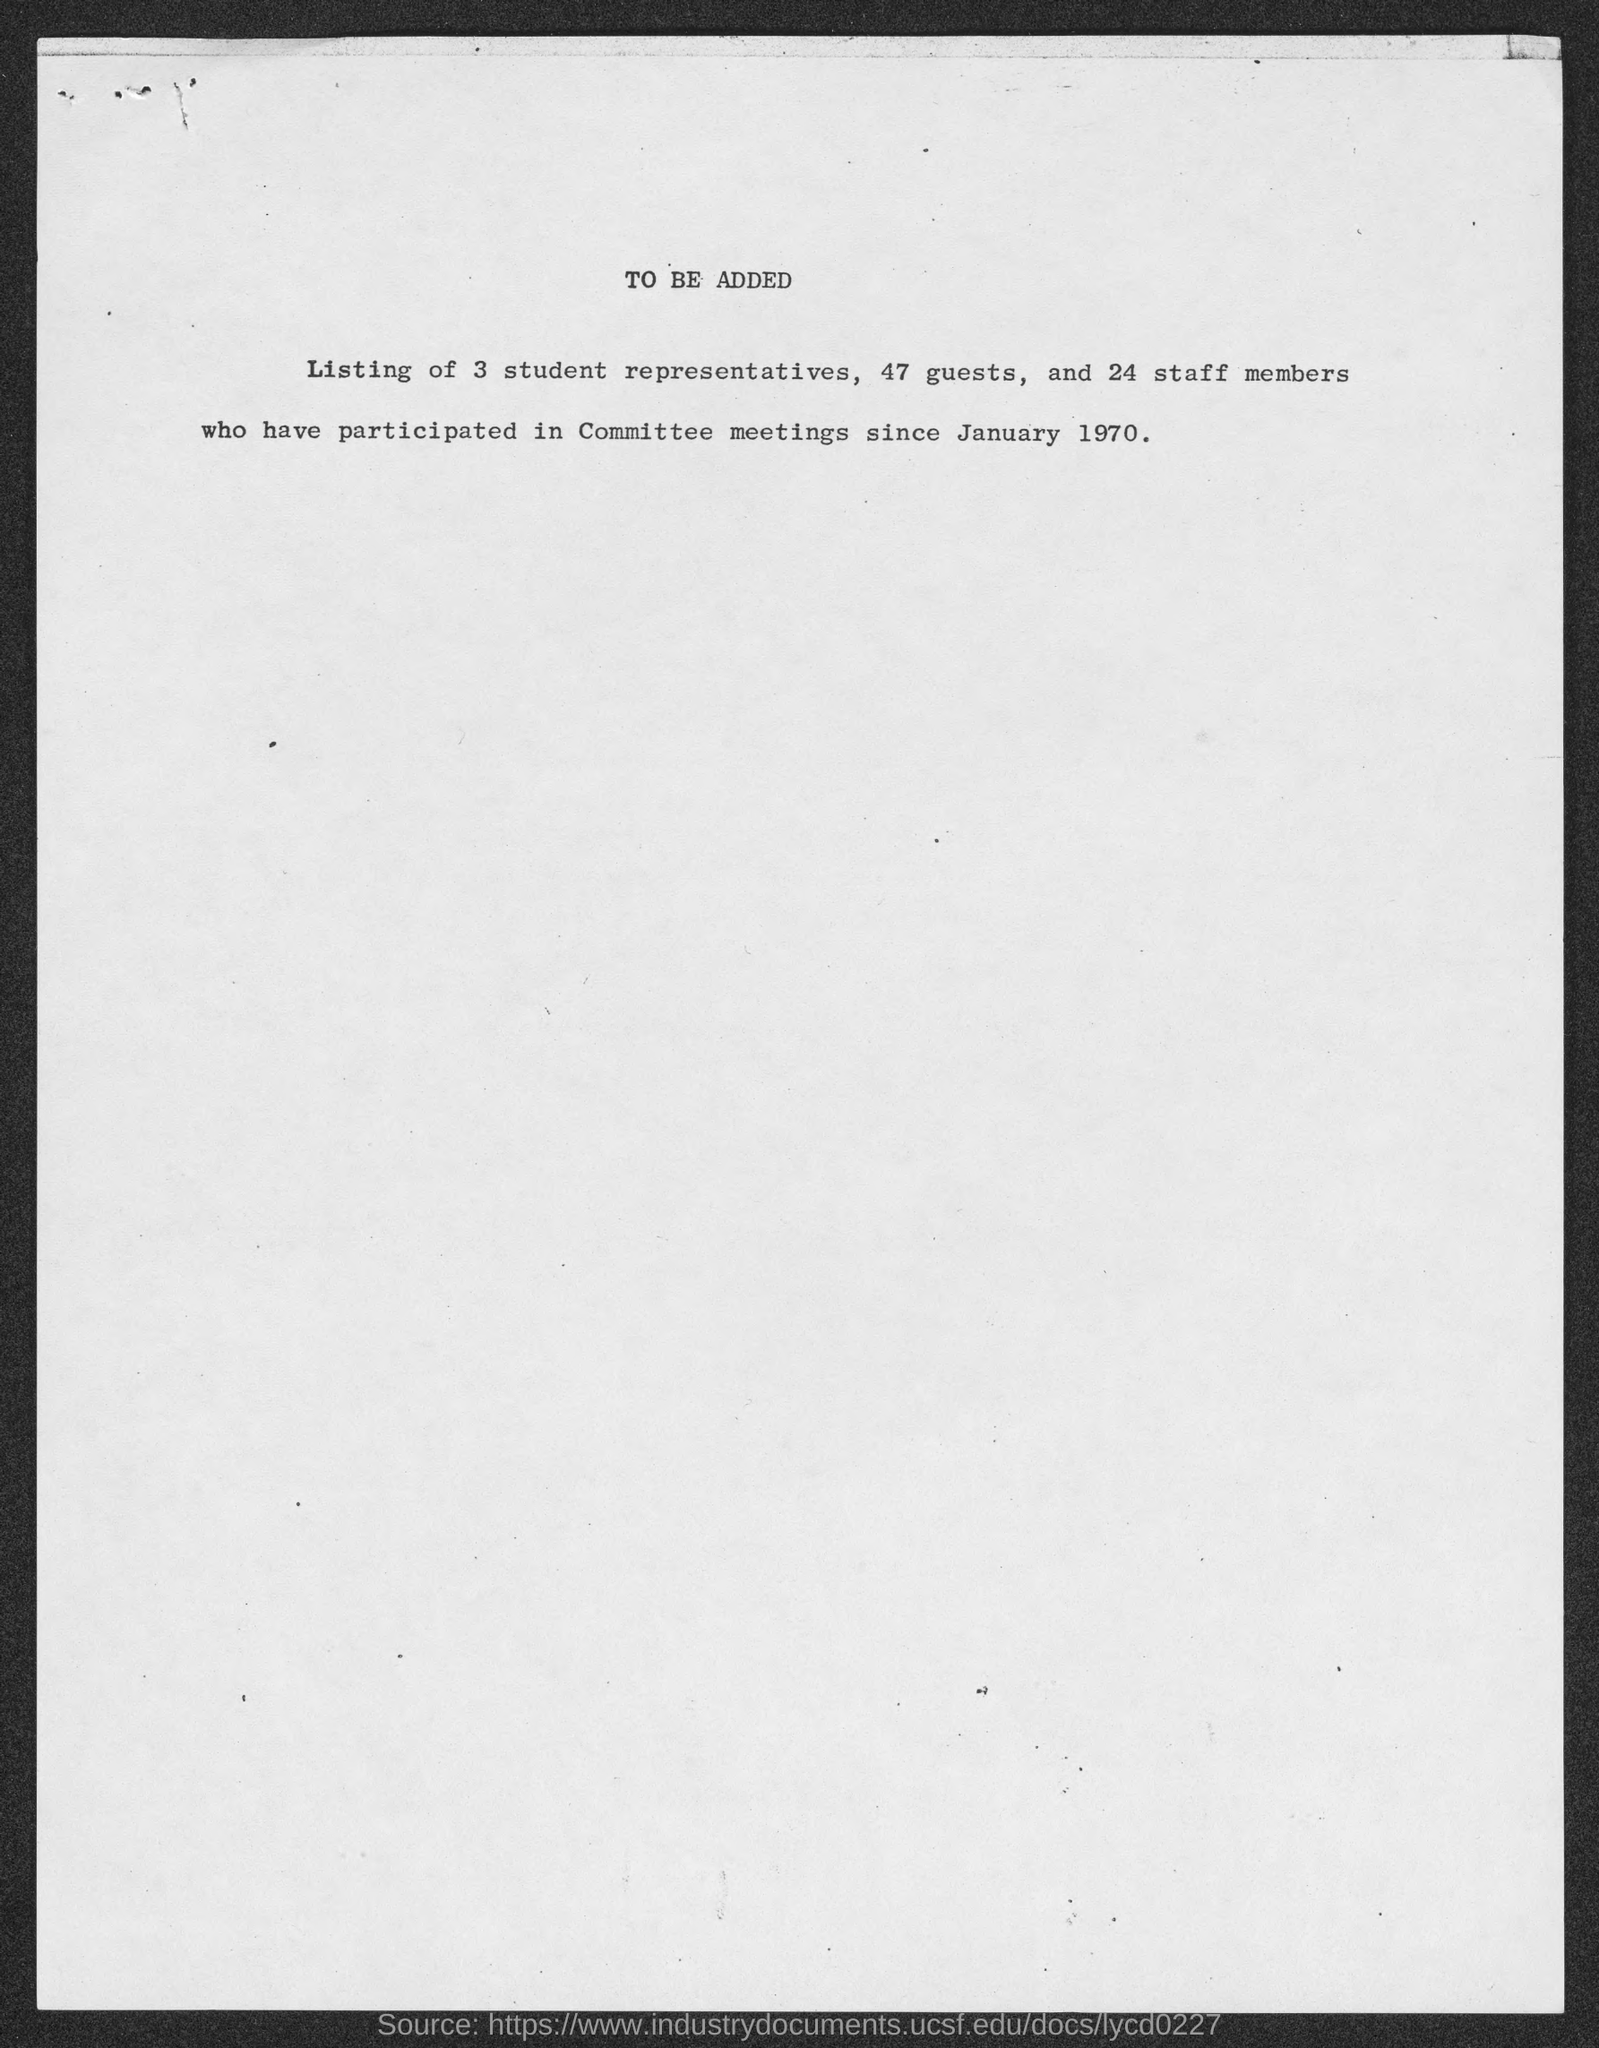Draw attention to some important aspects in this diagram. The document mentions that the date is January 1970. A total of 24 staff members have participated. Out of the total number of guests, 47 have participated. 